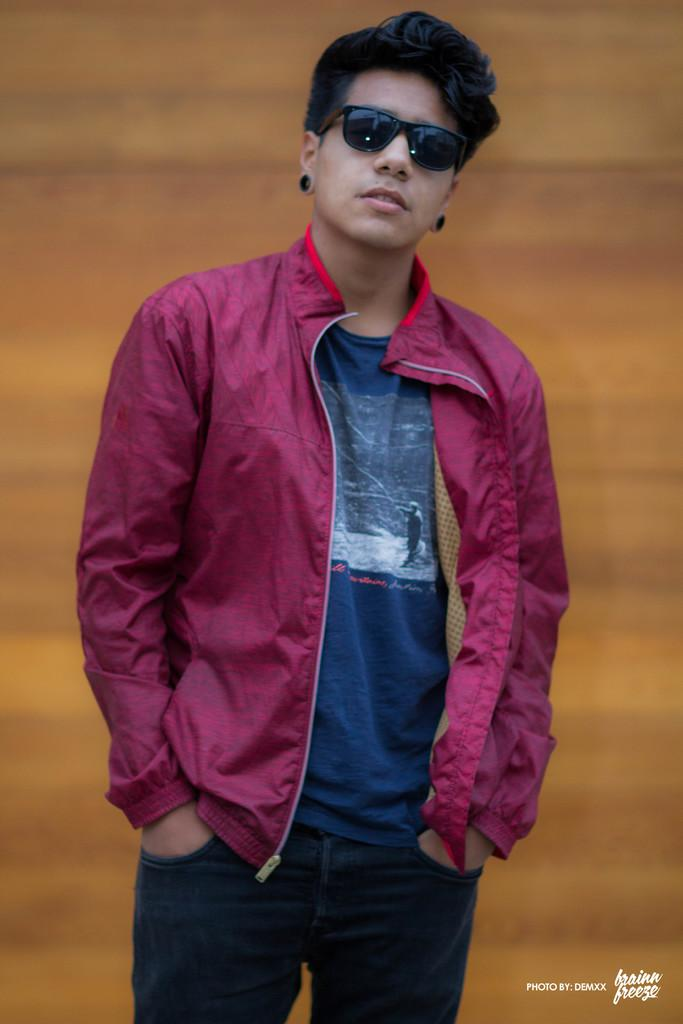Who is the main subject in the image? There is a man in the center of the image. What is the man wearing in the image? The man is wearing glasses in the image. What is the man's posture in the image? The man is standing in the image. How would you describe the background of the image? The background of the image is blurred. What can be found at the bottom of the image? There is text at the bottom of the image. What type of skate is the man using in the image? There is no skate present in the image; the man is standing. What kind of exchange is taking place between the man and the ship in the image? There is no ship present in the image, and no exchange is taking place. 